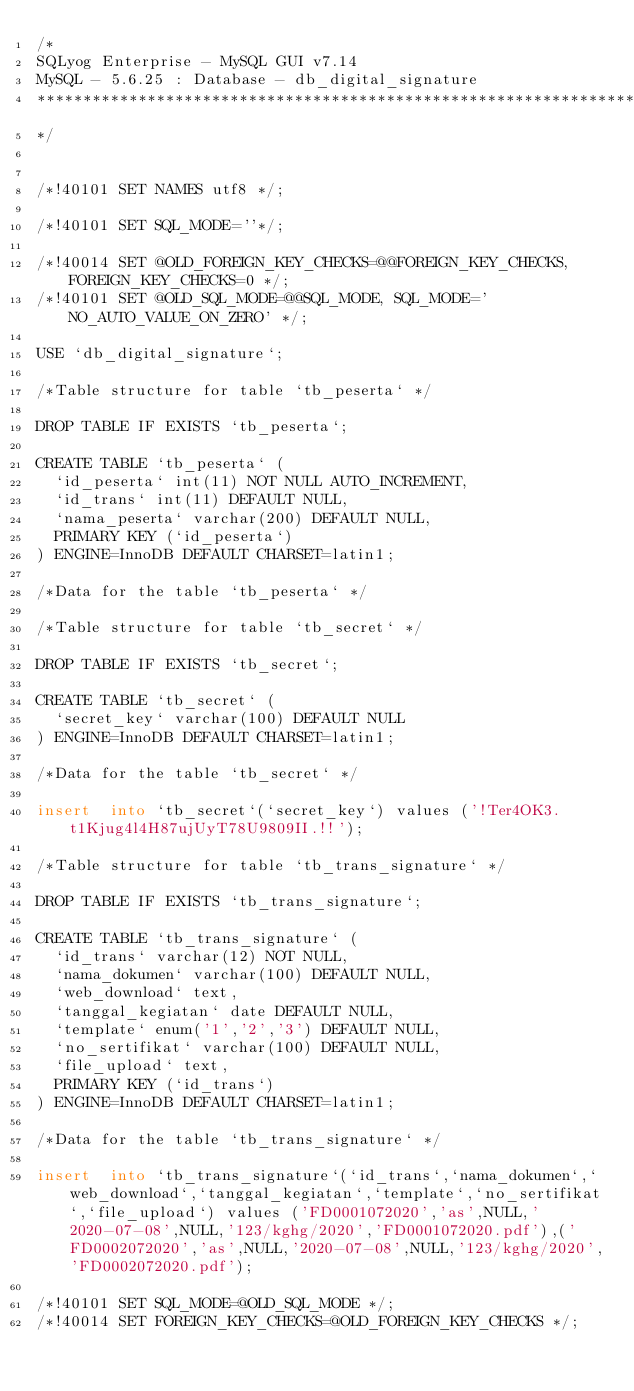Convert code to text. <code><loc_0><loc_0><loc_500><loc_500><_SQL_>/*
SQLyog Enterprise - MySQL GUI v7.14 
MySQL - 5.6.25 : Database - db_digital_signature
*********************************************************************
*/

/*!40101 SET NAMES utf8 */;

/*!40101 SET SQL_MODE=''*/;

/*!40014 SET @OLD_FOREIGN_KEY_CHECKS=@@FOREIGN_KEY_CHECKS, FOREIGN_KEY_CHECKS=0 */;
/*!40101 SET @OLD_SQL_MODE=@@SQL_MODE, SQL_MODE='NO_AUTO_VALUE_ON_ZERO' */;

USE `db_digital_signature`;

/*Table structure for table `tb_peserta` */

DROP TABLE IF EXISTS `tb_peserta`;

CREATE TABLE `tb_peserta` (
  `id_peserta` int(11) NOT NULL AUTO_INCREMENT,
  `id_trans` int(11) DEFAULT NULL,
  `nama_peserta` varchar(200) DEFAULT NULL,
  PRIMARY KEY (`id_peserta`)
) ENGINE=InnoDB DEFAULT CHARSET=latin1;

/*Data for the table `tb_peserta` */

/*Table structure for table `tb_secret` */

DROP TABLE IF EXISTS `tb_secret`;

CREATE TABLE `tb_secret` (
  `secret_key` varchar(100) DEFAULT NULL
) ENGINE=InnoDB DEFAULT CHARSET=latin1;

/*Data for the table `tb_secret` */

insert  into `tb_secret`(`secret_key`) values ('!Ter4OK3.t1Kjug4l4H87ujUyT78U9809II.!!');

/*Table structure for table `tb_trans_signature` */

DROP TABLE IF EXISTS `tb_trans_signature`;

CREATE TABLE `tb_trans_signature` (
  `id_trans` varchar(12) NOT NULL,
  `nama_dokumen` varchar(100) DEFAULT NULL,
  `web_download` text,
  `tanggal_kegiatan` date DEFAULT NULL,
  `template` enum('1','2','3') DEFAULT NULL,
  `no_sertifikat` varchar(100) DEFAULT NULL,
  `file_upload` text,
  PRIMARY KEY (`id_trans`)
) ENGINE=InnoDB DEFAULT CHARSET=latin1;

/*Data for the table `tb_trans_signature` */

insert  into `tb_trans_signature`(`id_trans`,`nama_dokumen`,`web_download`,`tanggal_kegiatan`,`template`,`no_sertifikat`,`file_upload`) values ('FD0001072020','as',NULL,'2020-07-08',NULL,'123/kghg/2020','FD0001072020.pdf'),('FD0002072020','as',NULL,'2020-07-08',NULL,'123/kghg/2020','FD0002072020.pdf');

/*!40101 SET SQL_MODE=@OLD_SQL_MODE */;
/*!40014 SET FOREIGN_KEY_CHECKS=@OLD_FOREIGN_KEY_CHECKS */;
</code> 